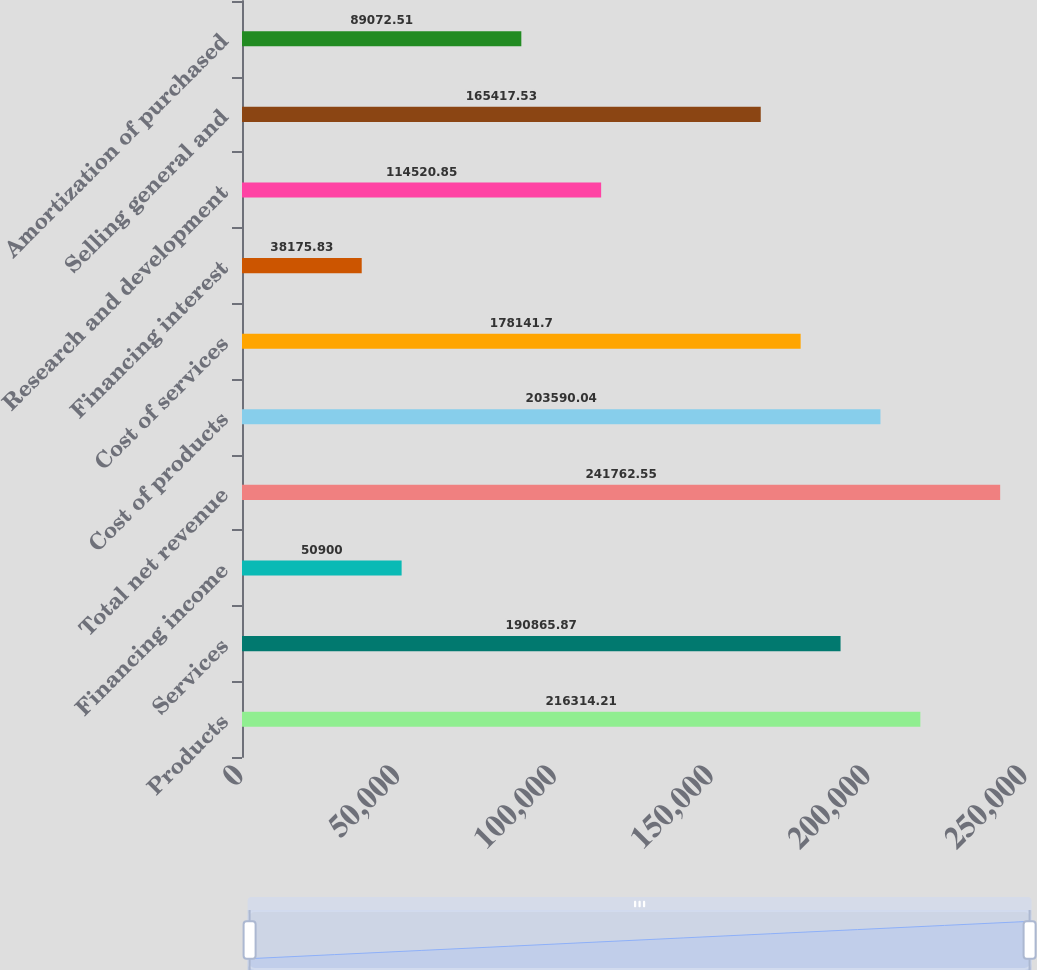<chart> <loc_0><loc_0><loc_500><loc_500><bar_chart><fcel>Products<fcel>Services<fcel>Financing income<fcel>Total net revenue<fcel>Cost of products<fcel>Cost of services<fcel>Financing interest<fcel>Research and development<fcel>Selling general and<fcel>Amortization of purchased<nl><fcel>216314<fcel>190866<fcel>50900<fcel>241763<fcel>203590<fcel>178142<fcel>38175.8<fcel>114521<fcel>165418<fcel>89072.5<nl></chart> 